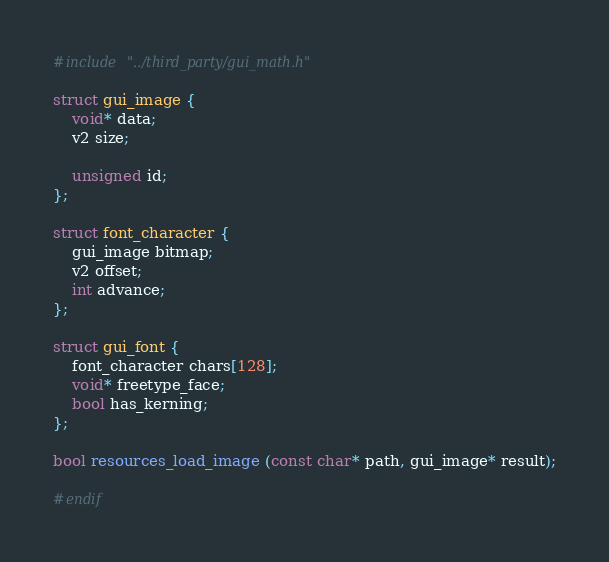Convert code to text. <code><loc_0><loc_0><loc_500><loc_500><_C_>#include "../third_party/gui_math.h"

struct gui_image {
	void* data;
	v2 size;

	unsigned id;
};

struct font_character {
	gui_image bitmap;
	v2 offset;
	int advance;
};

struct gui_font {
	font_character chars[128];
	void* freetype_face;
	bool has_kerning;
};

bool resources_load_image (const char* path, gui_image* result);

#endif</code> 